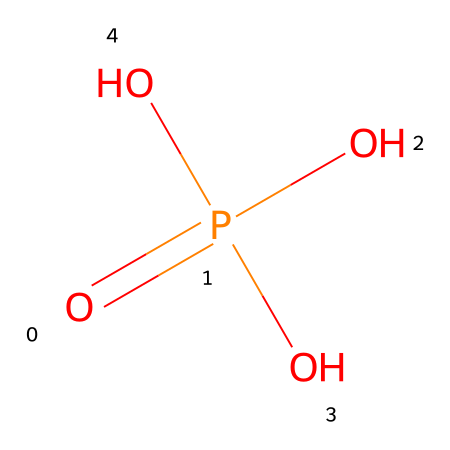What is the main functional group in phosphoric acid? The structure contains multiple hydroxyl groups (-OH) attached to a phosphorus atom, which is characteristic of acids. The presence of these groups identifies the main functional group as phosphate.
Answer: phosphate How many oxygen atoms are present in phosphoric acid? By analyzing the SMILES representation, O=P(O)(O)O indicates there are four oxygen atoms in total (three from the hydroxyl groups and one double-bonded to phosphorus).
Answer: four What is the oxidation state of phosphorus in phosphoric acid? In the structure, phosphorus is bonded to four oxygen atoms, one with a double bond and three with single bonds. This configuration indicates phosphorus is in the +5 oxidation state.
Answer: +5 What type of acid is phosphoric acid? Phosphoric acid is categorized as a triprotic acid because it has three acidic hydrogen atoms that can dissociate in solution, allowing it to donate three protons.
Answer: triprotic Is phosphoric acid considered a strong or weak acid? The dissociation constant indicates that phosphoric acid is not completely ionized in solution, classifying it as a weak acid.
Answer: weak What role does phosphoric acid play in the etching process of circuit boards? Phosphoric acid is used to etch metal surfaces by reacting with the metal substrates, which helps remove unwanted material during the manufacturing of circuit boards.
Answer: etching agent 